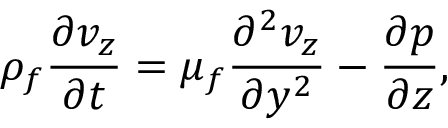Convert formula to latex. <formula><loc_0><loc_0><loc_500><loc_500>\rho _ { f } \frac { \partial v _ { z } } { \partial t } = \mu _ { f } \frac { \partial ^ { 2 } v _ { z } } { \partial y ^ { 2 } } - \frac { \partial p } { \partial z } ,</formula> 